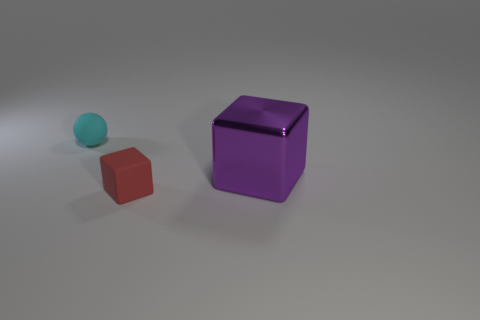What textures are present on the objects in the image? The objects in the image appear to have a matte finish with no significant reflections, indicative of a non-glossy texture. 